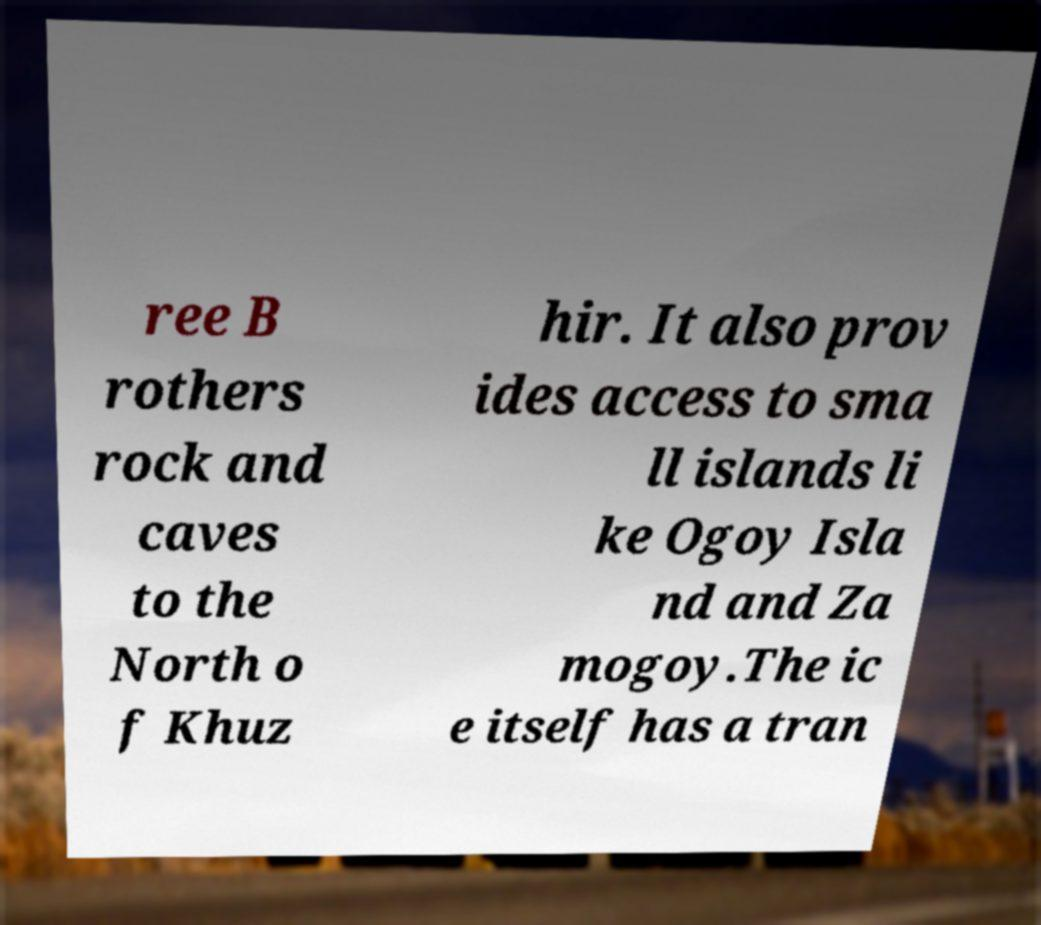Could you extract and type out the text from this image? ree B rothers rock and caves to the North o f Khuz hir. It also prov ides access to sma ll islands li ke Ogoy Isla nd and Za mogoy.The ic e itself has a tran 